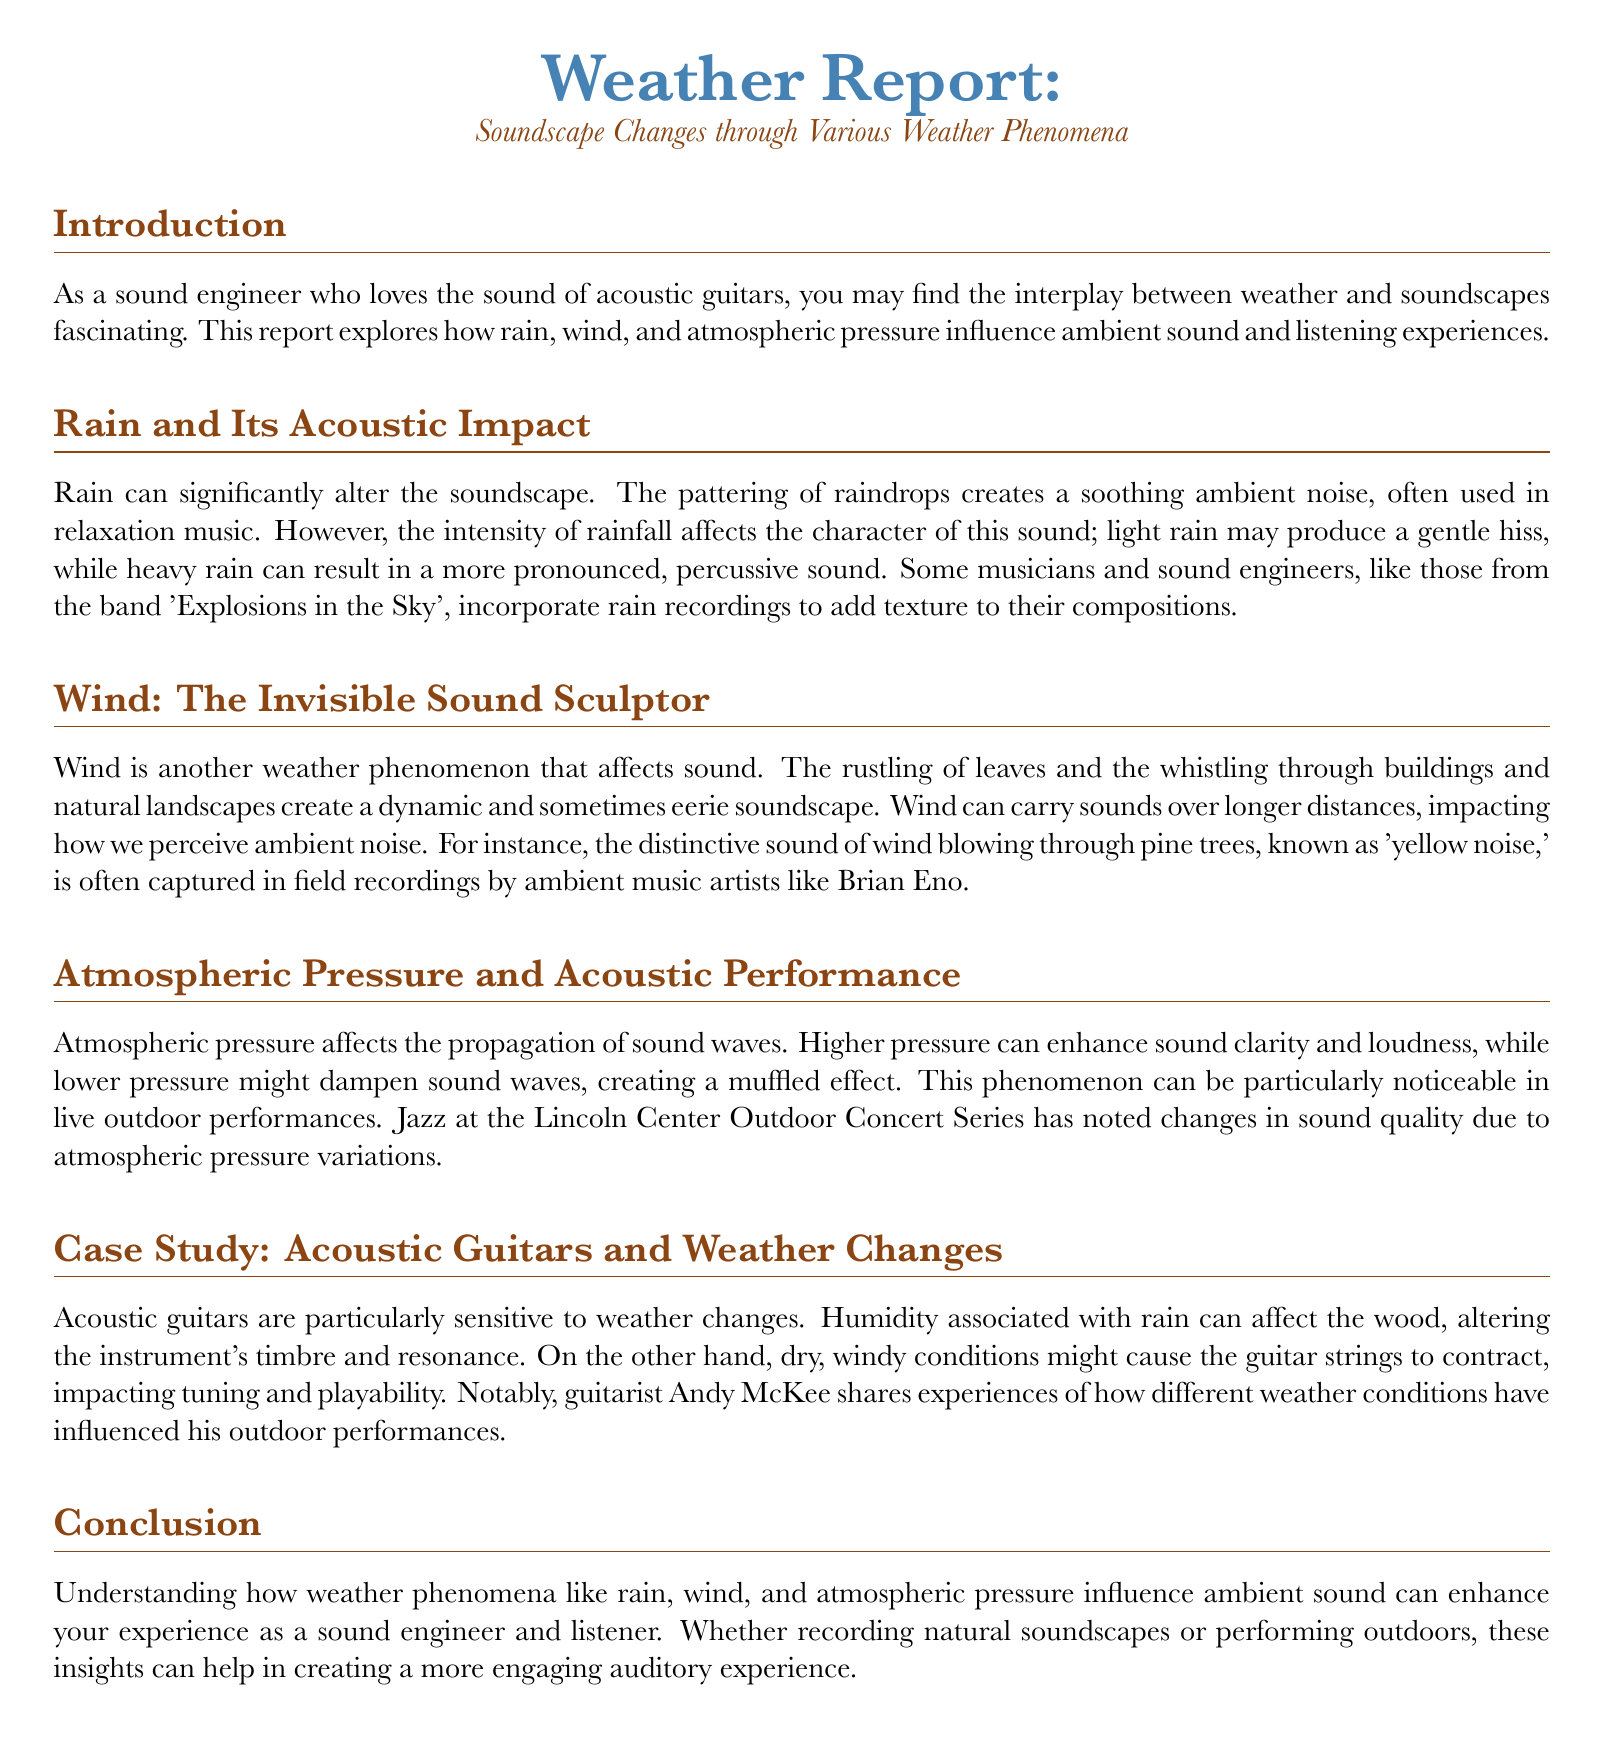What is the title of the report? The title is explicitly stated at the beginning of the document.
Answer: Weather Report: Soundscape Changes through Various Weather Phenomena Who is mentioned as incorporating rain recordings in their compositions? The document cites a specific band that uses rain recordings.
Answer: Explosions in the Sky What sound is described as 'yellow noise'? The document identifies a specific natural sound associated with the wind.
Answer: The distinctive sound of wind blowing through pine trees How does higher atmospheric pressure affect sound? The document explains the impact of atmospheric pressure on sound clarity.
Answer: Enhances sound clarity and loudness Which guitarist shares experiences of how weather conditions influence performances? The document provides the name of a notable guitarist in this context.
Answer: Andy McKee What effect does light rain have on the soundscape? The document describes the acoustic impact of light rain.
Answer: Produces a gentle hiss What is a common use of rain sounds in music? The document mentions a context where rain sounds are utilized.
Answer: Relaxation music What phenomenon can create a muffled sound effect? This question relates to the impact of atmospheric conditions on sound.
Answer: Lower pressure 